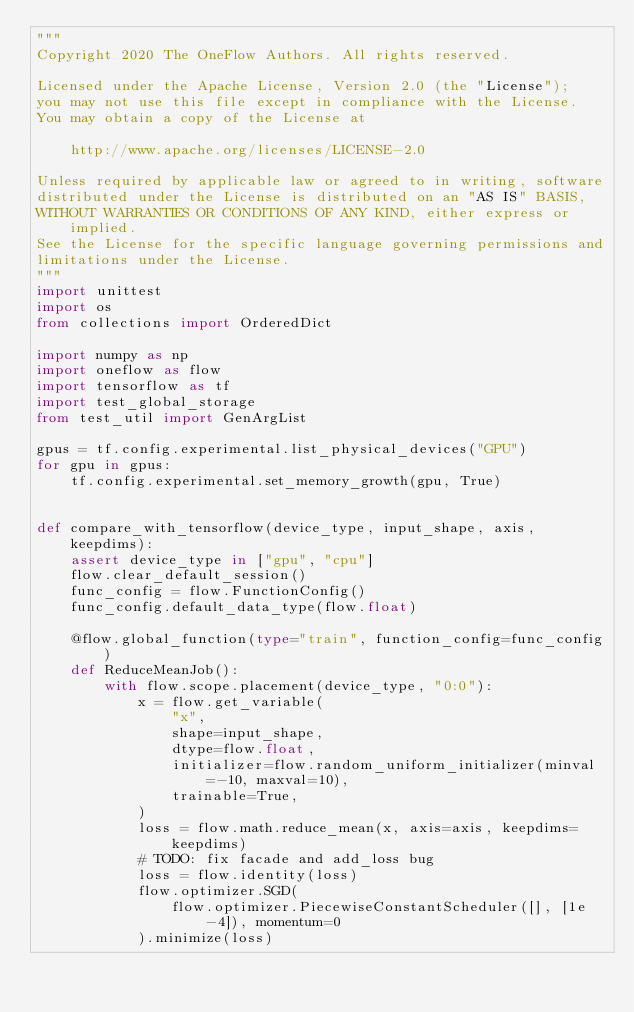Convert code to text. <code><loc_0><loc_0><loc_500><loc_500><_Python_>"""
Copyright 2020 The OneFlow Authors. All rights reserved.

Licensed under the Apache License, Version 2.0 (the "License");
you may not use this file except in compliance with the License.
You may obtain a copy of the License at

    http://www.apache.org/licenses/LICENSE-2.0

Unless required by applicable law or agreed to in writing, software
distributed under the License is distributed on an "AS IS" BASIS,
WITHOUT WARRANTIES OR CONDITIONS OF ANY KIND, either express or implied.
See the License for the specific language governing permissions and
limitations under the License.
"""
import unittest
import os
from collections import OrderedDict

import numpy as np
import oneflow as flow
import tensorflow as tf
import test_global_storage
from test_util import GenArgList

gpus = tf.config.experimental.list_physical_devices("GPU")
for gpu in gpus:
    tf.config.experimental.set_memory_growth(gpu, True)


def compare_with_tensorflow(device_type, input_shape, axis, keepdims):
    assert device_type in ["gpu", "cpu"]
    flow.clear_default_session()
    func_config = flow.FunctionConfig()
    func_config.default_data_type(flow.float)

    @flow.global_function(type="train", function_config=func_config)
    def ReduceMeanJob():
        with flow.scope.placement(device_type, "0:0"):
            x = flow.get_variable(
                "x",
                shape=input_shape,
                dtype=flow.float,
                initializer=flow.random_uniform_initializer(minval=-10, maxval=10),
                trainable=True,
            )
            loss = flow.math.reduce_mean(x, axis=axis, keepdims=keepdims)
            # TODO: fix facade and add_loss bug
            loss = flow.identity(loss)
            flow.optimizer.SGD(
                flow.optimizer.PiecewiseConstantScheduler([], [1e-4]), momentum=0
            ).minimize(loss)
</code> 